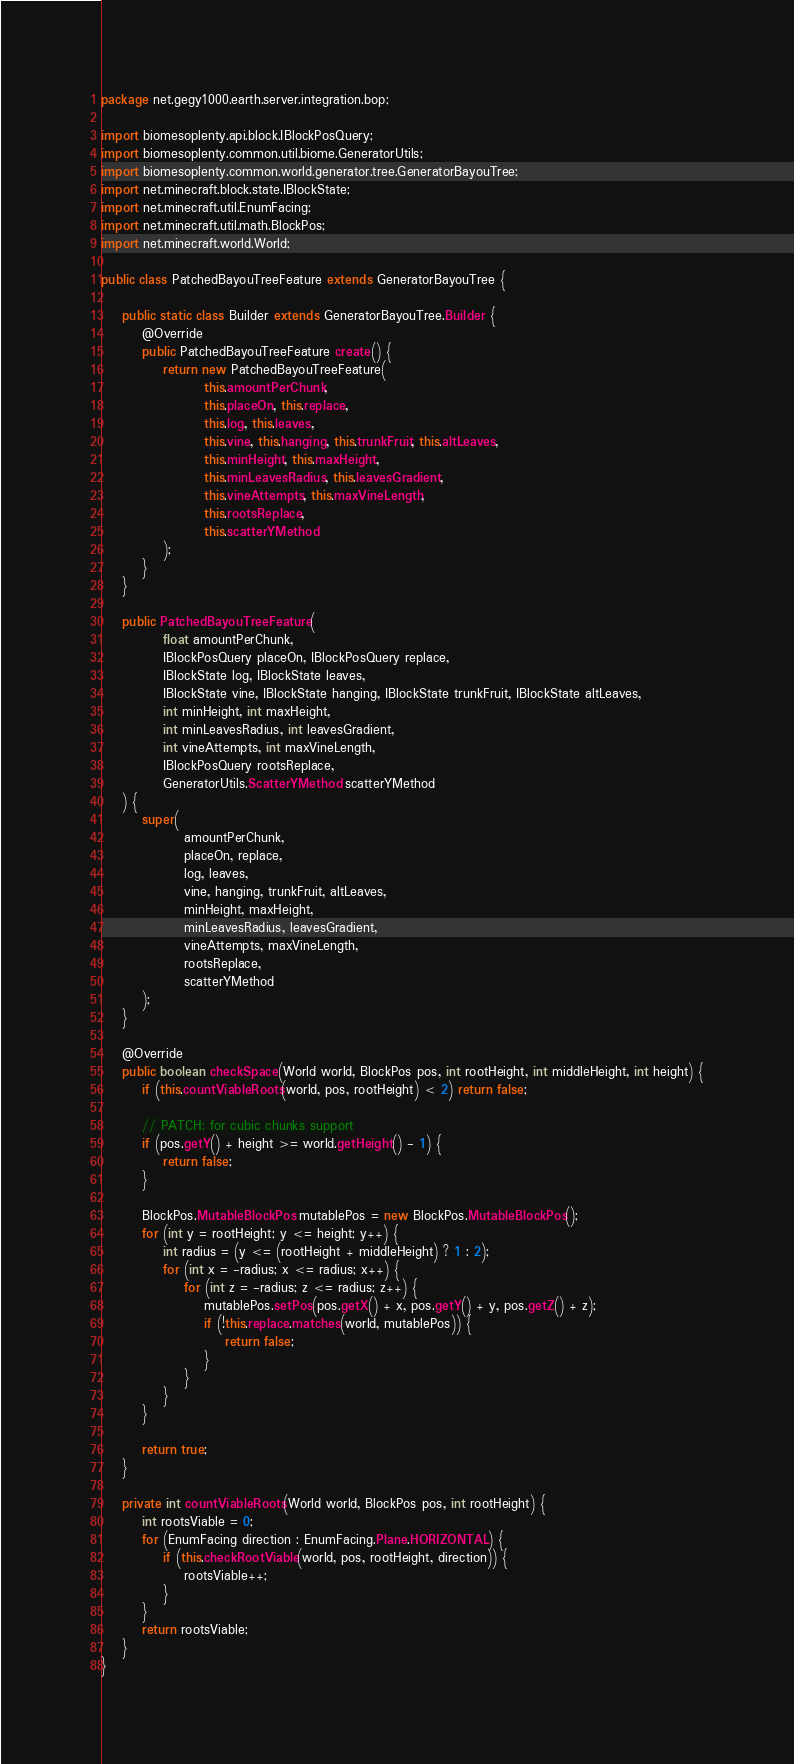<code> <loc_0><loc_0><loc_500><loc_500><_Java_>package net.gegy1000.earth.server.integration.bop;

import biomesoplenty.api.block.IBlockPosQuery;
import biomesoplenty.common.util.biome.GeneratorUtils;
import biomesoplenty.common.world.generator.tree.GeneratorBayouTree;
import net.minecraft.block.state.IBlockState;
import net.minecraft.util.EnumFacing;
import net.minecraft.util.math.BlockPos;
import net.minecraft.world.World;

public class PatchedBayouTreeFeature extends GeneratorBayouTree {

    public static class Builder extends GeneratorBayouTree.Builder {
        @Override
        public PatchedBayouTreeFeature create() {
            return new PatchedBayouTreeFeature(
                    this.amountPerChunk,
                    this.placeOn, this.replace,
                    this.log, this.leaves,
                    this.vine, this.hanging, this.trunkFruit, this.altLeaves,
                    this.minHeight, this.maxHeight,
                    this.minLeavesRadius, this.leavesGradient,
                    this.vineAttempts, this.maxVineLength,
                    this.rootsReplace,
                    this.scatterYMethod
            );
        }
    }

    public PatchedBayouTreeFeature(
            float amountPerChunk,
            IBlockPosQuery placeOn, IBlockPosQuery replace,
            IBlockState log, IBlockState leaves,
            IBlockState vine, IBlockState hanging, IBlockState trunkFruit, IBlockState altLeaves,
            int minHeight, int maxHeight,
            int minLeavesRadius, int leavesGradient,
            int vineAttempts, int maxVineLength,
            IBlockPosQuery rootsReplace,
            GeneratorUtils.ScatterYMethod scatterYMethod
    ) {
        super(
                amountPerChunk,
                placeOn, replace,
                log, leaves,
                vine, hanging, trunkFruit, altLeaves,
                minHeight, maxHeight,
                minLeavesRadius, leavesGradient,
                vineAttempts, maxVineLength,
                rootsReplace,
                scatterYMethod
        );
    }

    @Override
    public boolean checkSpace(World world, BlockPos pos, int rootHeight, int middleHeight, int height) {
        if (this.countViableRoots(world, pos, rootHeight) < 2) return false;

        // PATCH: for cubic chunks support
        if (pos.getY() + height >= world.getHeight() - 1) {
            return false;
        }

        BlockPos.MutableBlockPos mutablePos = new BlockPos.MutableBlockPos();
        for (int y = rootHeight; y <= height; y++) {
            int radius = (y <= (rootHeight + middleHeight) ? 1 : 2);
            for (int x = -radius; x <= radius; x++) {
                for (int z = -radius; z <= radius; z++) {
                    mutablePos.setPos(pos.getX() + x, pos.getY() + y, pos.getZ() + z);
                    if (!this.replace.matches(world, mutablePos)) {
                        return false;
                    }
                }
            }
        }

        return true;
    }

    private int countViableRoots(World world, BlockPos pos, int rootHeight) {
        int rootsViable = 0;
        for (EnumFacing direction : EnumFacing.Plane.HORIZONTAL) {
            if (this.checkRootViable(world, pos, rootHeight, direction)) {
                rootsViable++;
            }
        }
        return rootsViable;
    }
}
</code> 